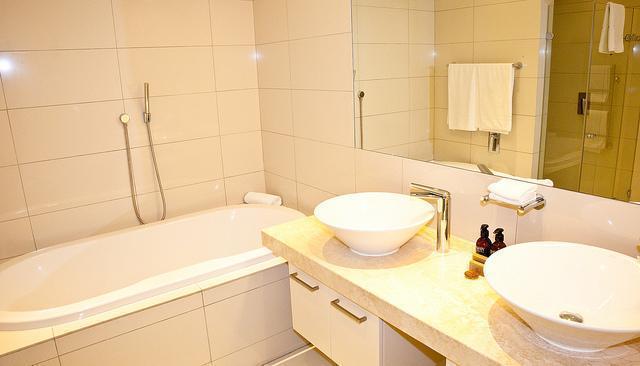What type of sinks are these?
Answer the question by selecting the correct answer among the 4 following choices.
Options: Top mount, under mount, bowl sinks, drop sinks. Bowl sinks. 